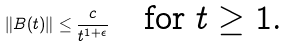Convert formula to latex. <formula><loc_0><loc_0><loc_500><loc_500>\| B ( t ) \| \leq \frac { c } { t ^ { 1 + \epsilon } } \quad \text {for $t\geq 1$.}</formula> 